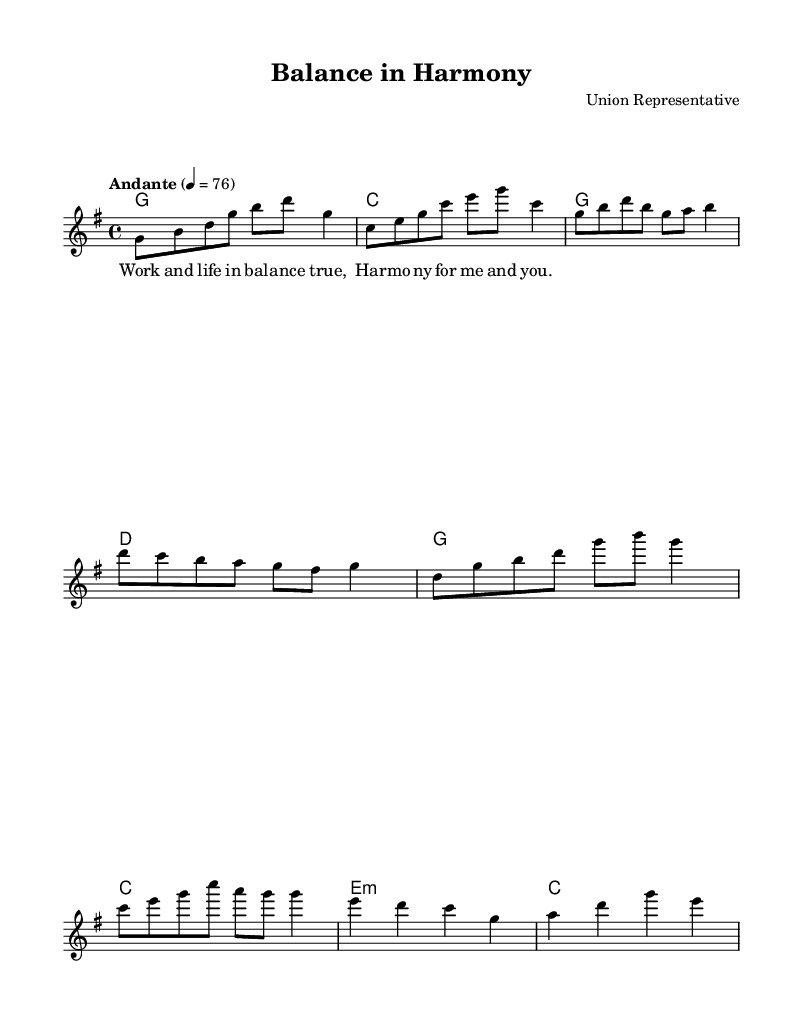What is the key signature of this music? The key signature is indicated by the notes and their corresponding sharps or flats, showing that there is one sharp (F#), which indicates that the piece is in G major.
Answer: G major What is the time signature of this music? The time signature is displayed at the beginning of the music, showing a 4 over 4, meaning there are four beats in each measure and the quarter note gets one beat.
Answer: 4/4 What is the tempo marking for this piece? The tempo marking is indicated in the score, which specifies the speed of the music; here it states "Andante," and includes a metronome marking of quarter note equals 76.
Answer: Andante How many measures are in the melody section? By counting the number of bars in the melody line presented, there are a total of 8 measures included in the melody section as represented in the score.
Answer: 8 What chords are used in the chorus section? The chorus section includes the chords G and C, as indicated by the provided harmonies, typical for K-pop ballads to use these major chords for a bright feeling.
Answer: G and C What lyrics are associated with the first verse? The lyrics for the first verse are specifically notated below the melody staff; they are succinctly provided as "Work and life in bal -- ance true, Har -- mo -- ny for me and you."
Answer: Work and life in balance true, Harmony for me and you What structural elements are typical for K-Pop ballads as seen in this piece? This piece includes a clear structure with verses, a chorus, and a bridge, which are common in K-Pop ballads to build emotional intensity and engage listeners. The sections are distinct and flow smoothly.
Answer: Verse, Chorus, Bridge 